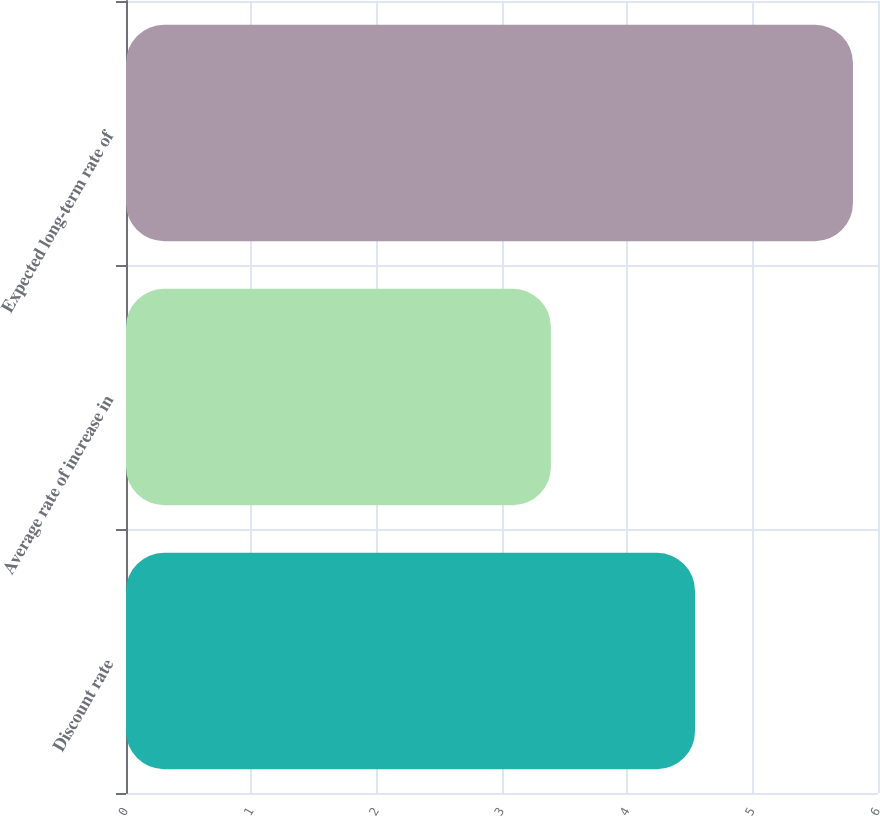<chart> <loc_0><loc_0><loc_500><loc_500><bar_chart><fcel>Discount rate<fcel>Average rate of increase in<fcel>Expected long-term rate of<nl><fcel>4.54<fcel>3.39<fcel>5.8<nl></chart> 